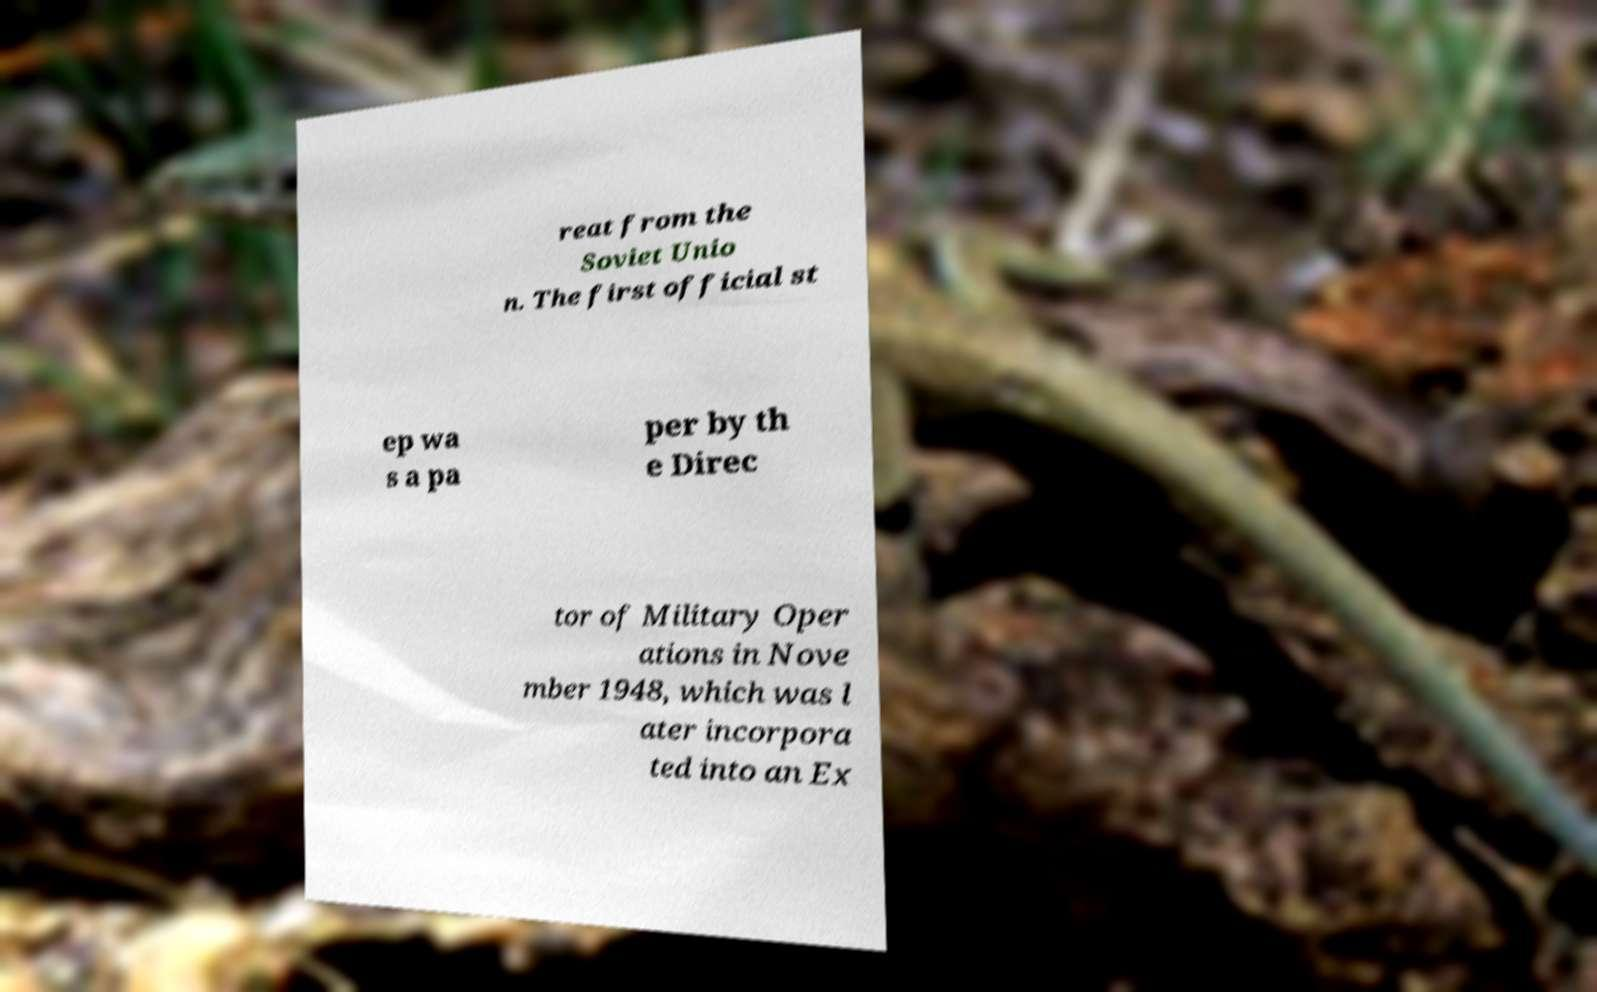Please read and relay the text visible in this image. What does it say? reat from the Soviet Unio n. The first official st ep wa s a pa per by th e Direc tor of Military Oper ations in Nove mber 1948, which was l ater incorpora ted into an Ex 